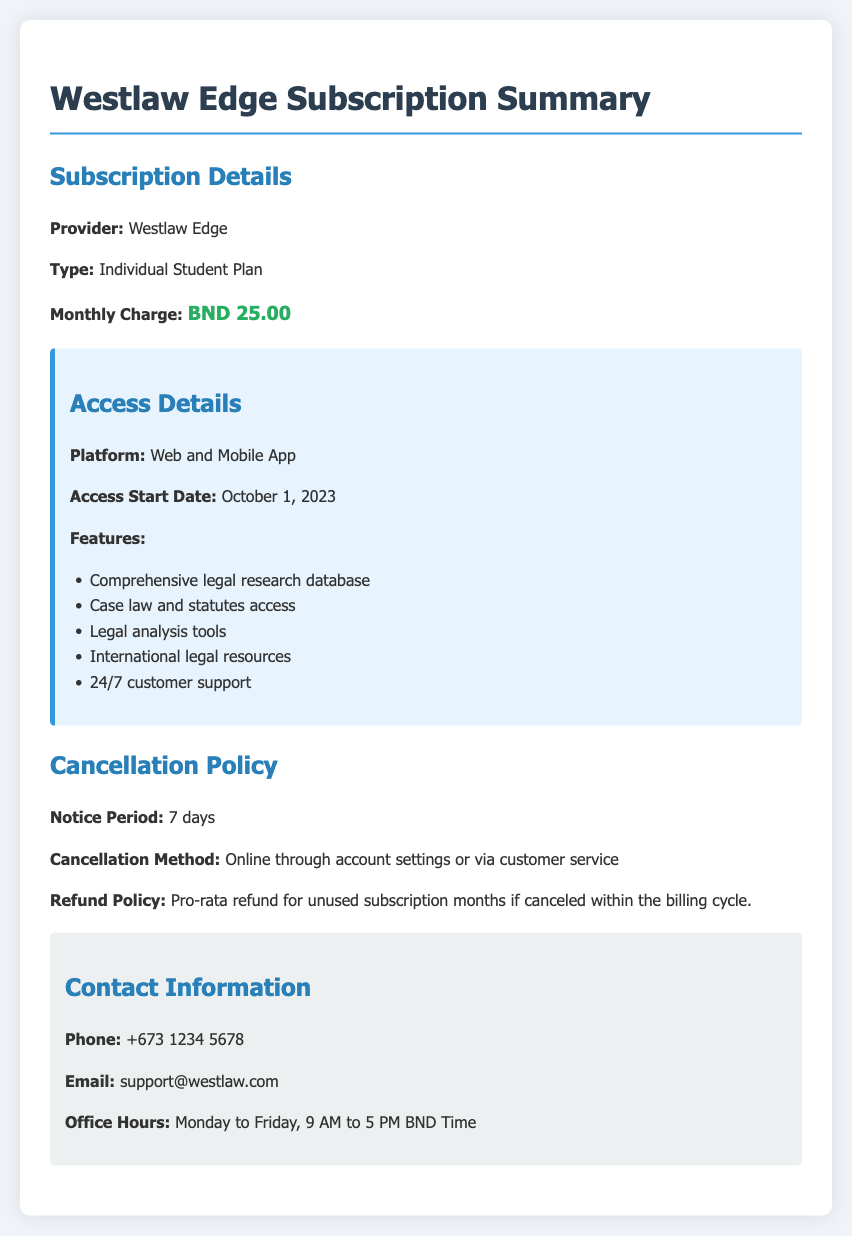What is the provider of the subscription? The provider of the subscription is mentioned in the document under Subscription Details.
Answer: Westlaw Edge What is the monthly charge for the subscription? The monthly charge is indicated specifically in the Subscription Details section of the document.
Answer: BND 25.00 When does the access start date begin? The start date is found in the Access Details section.
Answer: October 1, 2023 How many days notice is required for cancellation? The notice period for cancellation is stated in the Cancellation Policy section.
Answer: 7 days What platforms are available for accessing the subscription? The platforms for access are outlined in the Access Details section of the document.
Answer: Web and Mobile App What kind of refund policy is provided if canceled within the billing cycle? The refund policy is described in the Cancellation Policy section.
Answer: Pro-rata refund for unused subscription months What is the method of cancellation mentioned in the document? The cancellation method is detailed in the Cancellation Policy section.
Answer: Online through account settings or via customer service What are the office hours for customer support? The office hours are provided in the Contact Information section.
Answer: Monday to Friday, 9 AM to 5 PM BND Time 